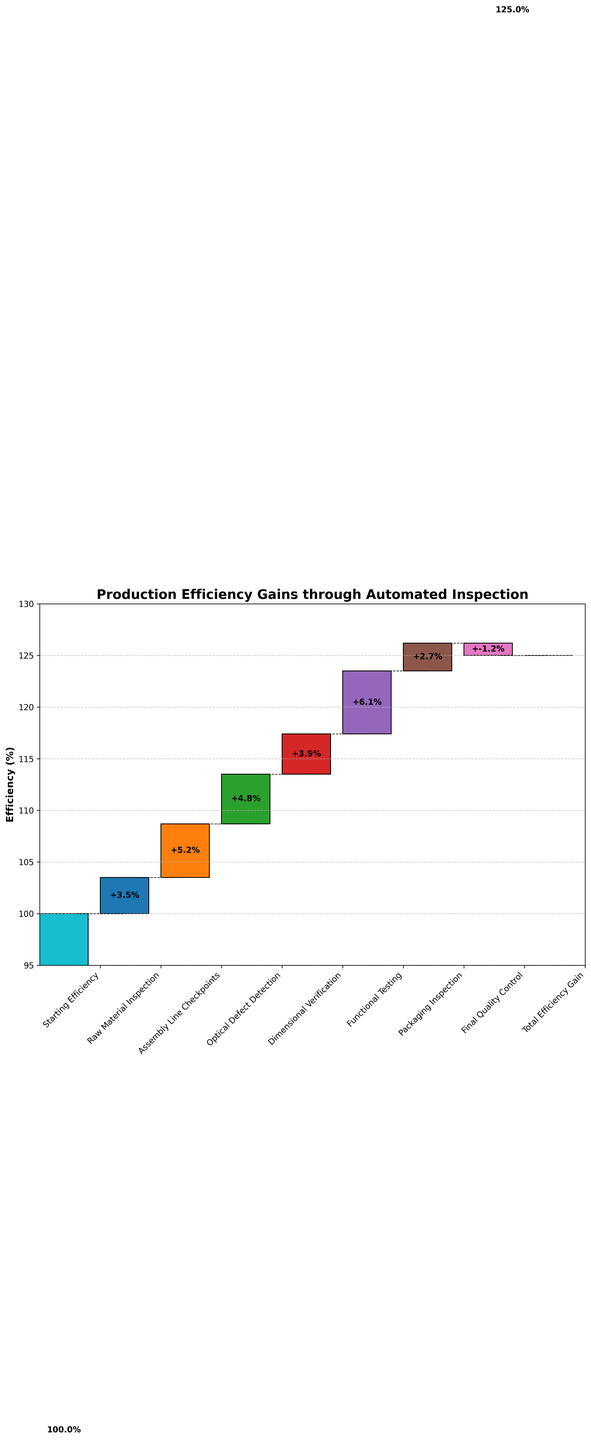How many categories are shown in the chart? Count all the tick labels along the x-axis of the chart. There are 9 categories in total including starting and final efficiencies.
Answer: 9 What is the title of the chart? Look at the top of the chart where the title is usually placed in larger font size. The title of the chart is "Production Efficiency Gains through Automated Inspection".
Answer: Production Efficiency Gains through Automated Inspection Which category provides the highest efficiency gain? Compare the value labels next to each bar. The category with the highest value label represents the highest efficiency gain. Functional Testing has the highest efficiency gain of +6.1%.
Answer: Functional Testing Which category has a negative efficiency value and what is it? Identify the category with a value label that has a negative sign. The only negative efficiency value is from the Final Quality Control with -1.2%.
Answer: Final Quality Control, -1.2% What is the total efficiency gain shown in the chart? The total efficiency gain is recorded at the end of the chart, usually through final cumulative values. The total efficiency gain is shown as 125%.
Answer: 125% What is the cumulative efficiency after Dimensional Verification? Sum the values step-by-step up to Dimensional Verification: 100 + 3.5 + 5.2 + 4.8 + 3.9 = 117.4%.
Answer: 117.4% How much more efficiency does Functional Testing add compared to Packaging Inspection? Subtract the efficiency value of Packaging Inspection from Functional Testing: 6.1 - 2.7 = 3.4%.
Answer: 3.4% What is the cumulative efficiency compared to the initial starting efficiency? Compare the cumulative final value to the initial starting value: The final efficiency gain is 125%, starting from 100%. Therefore, the increase is 125% - 100% = 25%.
Answer: 25% Did the efficiency gain ever decrease? When? Look for negative values within the middle categories. The efficiency gain decreased only once during the Final Quality Control with a decrease of -1.2%.
Answer: Yes, during Final Quality Control Combine Raw Material Inspection and Assembly Line Checkpoints efficiency gains. What is the sum? Add the efficiency gains of Raw Material Inspection and Assembly Line Checkpoints: 3.5 + 5.2 = 8.7%.
Answer: 8.7% 